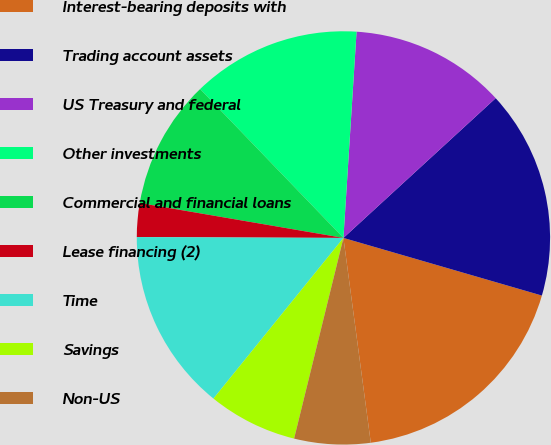<chart> <loc_0><loc_0><loc_500><loc_500><pie_chart><fcel>Interest-bearing deposits with<fcel>Trading account assets<fcel>US Treasury and federal<fcel>Other investments<fcel>Commercial and financial loans<fcel>Lease financing (2)<fcel>Time<fcel>Savings<fcel>Non-US<nl><fcel>18.39%<fcel>16.32%<fcel>12.17%<fcel>13.21%<fcel>10.1%<fcel>2.64%<fcel>14.24%<fcel>6.99%<fcel>5.95%<nl></chart> 